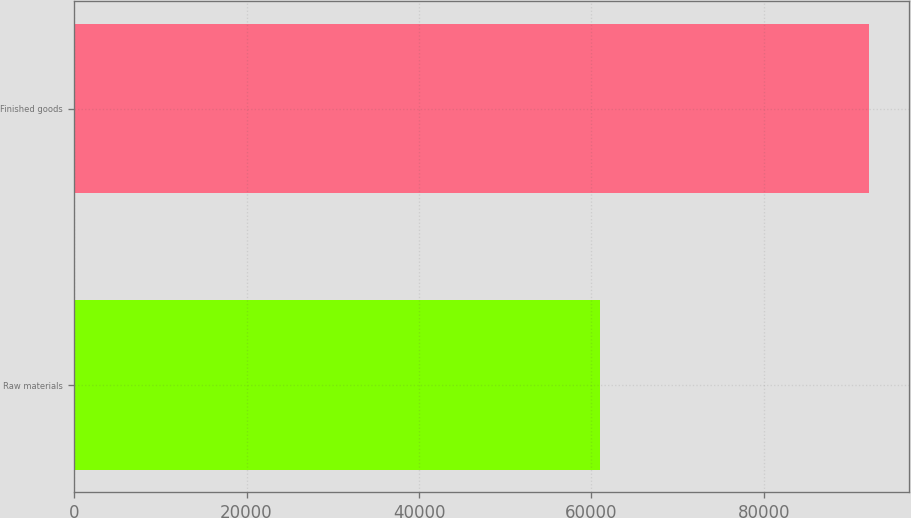Convert chart to OTSL. <chart><loc_0><loc_0><loc_500><loc_500><bar_chart><fcel>Raw materials<fcel>Finished goods<nl><fcel>61010<fcel>92231<nl></chart> 